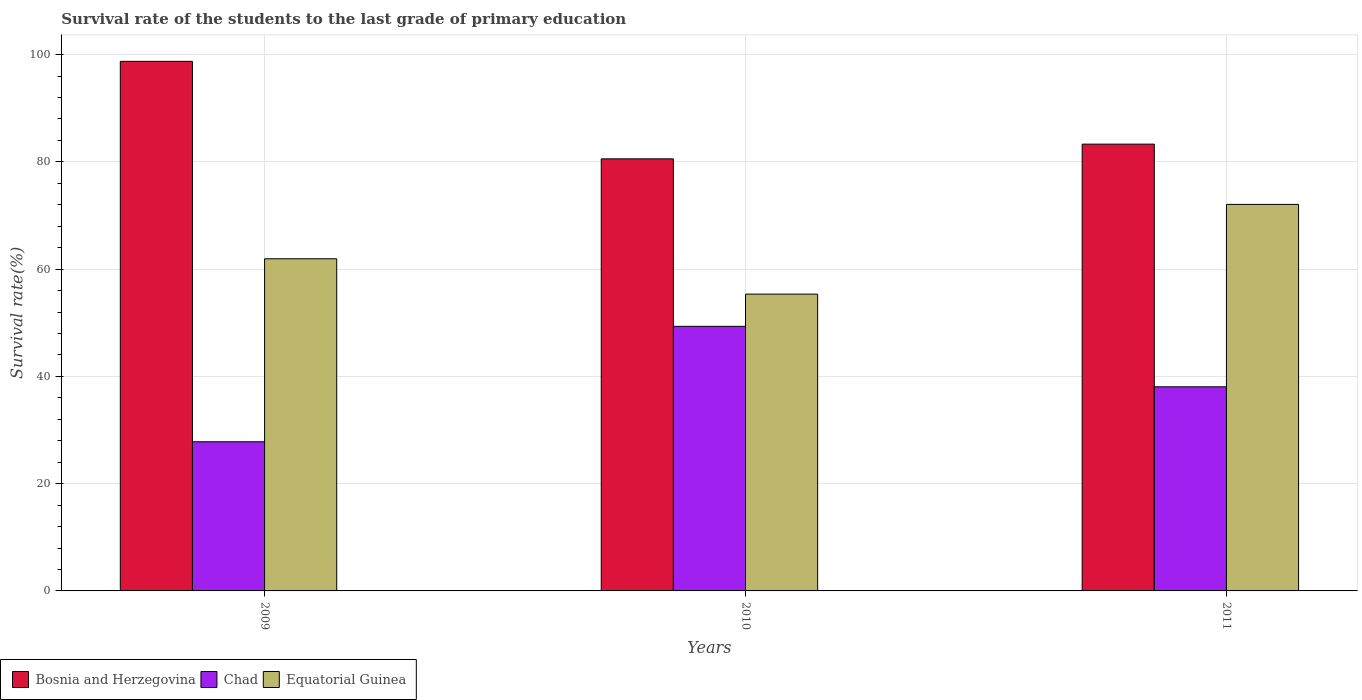How many groups of bars are there?
Your response must be concise. 3. Are the number of bars per tick equal to the number of legend labels?
Make the answer very short. Yes. What is the survival rate of the students in Chad in 2009?
Provide a short and direct response. 27.81. Across all years, what is the maximum survival rate of the students in Equatorial Guinea?
Ensure brevity in your answer.  72.07. Across all years, what is the minimum survival rate of the students in Chad?
Your answer should be compact. 27.81. What is the total survival rate of the students in Equatorial Guinea in the graph?
Provide a short and direct response. 189.34. What is the difference between the survival rate of the students in Equatorial Guinea in 2010 and that in 2011?
Keep it short and to the point. -16.73. What is the difference between the survival rate of the students in Equatorial Guinea in 2010 and the survival rate of the students in Bosnia and Herzegovina in 2009?
Your answer should be very brief. -43.4. What is the average survival rate of the students in Equatorial Guinea per year?
Your answer should be compact. 63.11. In the year 2010, what is the difference between the survival rate of the students in Equatorial Guinea and survival rate of the students in Bosnia and Herzegovina?
Ensure brevity in your answer.  -25.22. What is the ratio of the survival rate of the students in Equatorial Guinea in 2009 to that in 2011?
Provide a short and direct response. 0.86. Is the difference between the survival rate of the students in Equatorial Guinea in 2009 and 2011 greater than the difference between the survival rate of the students in Bosnia and Herzegovina in 2009 and 2011?
Ensure brevity in your answer.  No. What is the difference between the highest and the second highest survival rate of the students in Bosnia and Herzegovina?
Make the answer very short. 15.44. What is the difference between the highest and the lowest survival rate of the students in Bosnia and Herzegovina?
Your response must be concise. 18.18. What does the 3rd bar from the left in 2010 represents?
Give a very brief answer. Equatorial Guinea. What does the 3rd bar from the right in 2011 represents?
Offer a terse response. Bosnia and Herzegovina. Is it the case that in every year, the sum of the survival rate of the students in Bosnia and Herzegovina and survival rate of the students in Equatorial Guinea is greater than the survival rate of the students in Chad?
Provide a short and direct response. Yes. Are all the bars in the graph horizontal?
Your answer should be compact. No. Does the graph contain any zero values?
Your answer should be very brief. No. Where does the legend appear in the graph?
Ensure brevity in your answer.  Bottom left. How many legend labels are there?
Your response must be concise. 3. What is the title of the graph?
Provide a succinct answer. Survival rate of the students to the last grade of primary education. What is the label or title of the Y-axis?
Offer a very short reply. Survival rate(%). What is the Survival rate(%) in Bosnia and Herzegovina in 2009?
Offer a terse response. 98.74. What is the Survival rate(%) in Chad in 2009?
Offer a very short reply. 27.81. What is the Survival rate(%) of Equatorial Guinea in 2009?
Provide a short and direct response. 61.93. What is the Survival rate(%) of Bosnia and Herzegovina in 2010?
Your answer should be compact. 80.56. What is the Survival rate(%) in Chad in 2010?
Provide a succinct answer. 49.34. What is the Survival rate(%) of Equatorial Guinea in 2010?
Offer a terse response. 55.34. What is the Survival rate(%) in Bosnia and Herzegovina in 2011?
Ensure brevity in your answer.  83.31. What is the Survival rate(%) in Chad in 2011?
Give a very brief answer. 38.06. What is the Survival rate(%) in Equatorial Guinea in 2011?
Your answer should be very brief. 72.07. Across all years, what is the maximum Survival rate(%) of Bosnia and Herzegovina?
Your response must be concise. 98.74. Across all years, what is the maximum Survival rate(%) of Chad?
Your response must be concise. 49.34. Across all years, what is the maximum Survival rate(%) of Equatorial Guinea?
Make the answer very short. 72.07. Across all years, what is the minimum Survival rate(%) of Bosnia and Herzegovina?
Offer a terse response. 80.56. Across all years, what is the minimum Survival rate(%) of Chad?
Offer a very short reply. 27.81. Across all years, what is the minimum Survival rate(%) in Equatorial Guinea?
Your response must be concise. 55.34. What is the total Survival rate(%) of Bosnia and Herzegovina in the graph?
Offer a very short reply. 262.61. What is the total Survival rate(%) of Chad in the graph?
Give a very brief answer. 115.2. What is the total Survival rate(%) of Equatorial Guinea in the graph?
Provide a succinct answer. 189.34. What is the difference between the Survival rate(%) of Bosnia and Herzegovina in 2009 and that in 2010?
Give a very brief answer. 18.18. What is the difference between the Survival rate(%) in Chad in 2009 and that in 2010?
Make the answer very short. -21.53. What is the difference between the Survival rate(%) of Equatorial Guinea in 2009 and that in 2010?
Offer a terse response. 6.59. What is the difference between the Survival rate(%) in Bosnia and Herzegovina in 2009 and that in 2011?
Keep it short and to the point. 15.44. What is the difference between the Survival rate(%) in Chad in 2009 and that in 2011?
Keep it short and to the point. -10.25. What is the difference between the Survival rate(%) of Equatorial Guinea in 2009 and that in 2011?
Provide a short and direct response. -10.14. What is the difference between the Survival rate(%) in Bosnia and Herzegovina in 2010 and that in 2011?
Offer a terse response. -2.74. What is the difference between the Survival rate(%) of Chad in 2010 and that in 2011?
Ensure brevity in your answer.  11.28. What is the difference between the Survival rate(%) of Equatorial Guinea in 2010 and that in 2011?
Ensure brevity in your answer.  -16.73. What is the difference between the Survival rate(%) in Bosnia and Herzegovina in 2009 and the Survival rate(%) in Chad in 2010?
Provide a succinct answer. 49.41. What is the difference between the Survival rate(%) of Bosnia and Herzegovina in 2009 and the Survival rate(%) of Equatorial Guinea in 2010?
Ensure brevity in your answer.  43.4. What is the difference between the Survival rate(%) of Chad in 2009 and the Survival rate(%) of Equatorial Guinea in 2010?
Your answer should be very brief. -27.53. What is the difference between the Survival rate(%) of Bosnia and Herzegovina in 2009 and the Survival rate(%) of Chad in 2011?
Ensure brevity in your answer.  60.68. What is the difference between the Survival rate(%) of Bosnia and Herzegovina in 2009 and the Survival rate(%) of Equatorial Guinea in 2011?
Make the answer very short. 26.67. What is the difference between the Survival rate(%) in Chad in 2009 and the Survival rate(%) in Equatorial Guinea in 2011?
Ensure brevity in your answer.  -44.26. What is the difference between the Survival rate(%) of Bosnia and Herzegovina in 2010 and the Survival rate(%) of Chad in 2011?
Provide a succinct answer. 42.51. What is the difference between the Survival rate(%) in Bosnia and Herzegovina in 2010 and the Survival rate(%) in Equatorial Guinea in 2011?
Offer a terse response. 8.49. What is the difference between the Survival rate(%) in Chad in 2010 and the Survival rate(%) in Equatorial Guinea in 2011?
Your answer should be compact. -22.73. What is the average Survival rate(%) of Bosnia and Herzegovina per year?
Give a very brief answer. 87.54. What is the average Survival rate(%) of Chad per year?
Make the answer very short. 38.4. What is the average Survival rate(%) of Equatorial Guinea per year?
Keep it short and to the point. 63.11. In the year 2009, what is the difference between the Survival rate(%) of Bosnia and Herzegovina and Survival rate(%) of Chad?
Provide a succinct answer. 70.93. In the year 2009, what is the difference between the Survival rate(%) in Bosnia and Herzegovina and Survival rate(%) in Equatorial Guinea?
Provide a short and direct response. 36.81. In the year 2009, what is the difference between the Survival rate(%) in Chad and Survival rate(%) in Equatorial Guinea?
Your answer should be very brief. -34.12. In the year 2010, what is the difference between the Survival rate(%) in Bosnia and Herzegovina and Survival rate(%) in Chad?
Make the answer very short. 31.23. In the year 2010, what is the difference between the Survival rate(%) in Bosnia and Herzegovina and Survival rate(%) in Equatorial Guinea?
Provide a short and direct response. 25.22. In the year 2010, what is the difference between the Survival rate(%) of Chad and Survival rate(%) of Equatorial Guinea?
Give a very brief answer. -6.01. In the year 2011, what is the difference between the Survival rate(%) in Bosnia and Herzegovina and Survival rate(%) in Chad?
Provide a succinct answer. 45.25. In the year 2011, what is the difference between the Survival rate(%) in Bosnia and Herzegovina and Survival rate(%) in Equatorial Guinea?
Provide a succinct answer. 11.24. In the year 2011, what is the difference between the Survival rate(%) of Chad and Survival rate(%) of Equatorial Guinea?
Your response must be concise. -34.01. What is the ratio of the Survival rate(%) of Bosnia and Herzegovina in 2009 to that in 2010?
Your answer should be very brief. 1.23. What is the ratio of the Survival rate(%) in Chad in 2009 to that in 2010?
Your answer should be compact. 0.56. What is the ratio of the Survival rate(%) in Equatorial Guinea in 2009 to that in 2010?
Offer a terse response. 1.12. What is the ratio of the Survival rate(%) in Bosnia and Herzegovina in 2009 to that in 2011?
Offer a very short reply. 1.19. What is the ratio of the Survival rate(%) of Chad in 2009 to that in 2011?
Offer a terse response. 0.73. What is the ratio of the Survival rate(%) in Equatorial Guinea in 2009 to that in 2011?
Ensure brevity in your answer.  0.86. What is the ratio of the Survival rate(%) of Bosnia and Herzegovina in 2010 to that in 2011?
Offer a terse response. 0.97. What is the ratio of the Survival rate(%) in Chad in 2010 to that in 2011?
Ensure brevity in your answer.  1.3. What is the ratio of the Survival rate(%) in Equatorial Guinea in 2010 to that in 2011?
Provide a succinct answer. 0.77. What is the difference between the highest and the second highest Survival rate(%) in Bosnia and Herzegovina?
Ensure brevity in your answer.  15.44. What is the difference between the highest and the second highest Survival rate(%) in Chad?
Keep it short and to the point. 11.28. What is the difference between the highest and the second highest Survival rate(%) in Equatorial Guinea?
Keep it short and to the point. 10.14. What is the difference between the highest and the lowest Survival rate(%) in Bosnia and Herzegovina?
Ensure brevity in your answer.  18.18. What is the difference between the highest and the lowest Survival rate(%) of Chad?
Your answer should be very brief. 21.53. What is the difference between the highest and the lowest Survival rate(%) in Equatorial Guinea?
Provide a short and direct response. 16.73. 